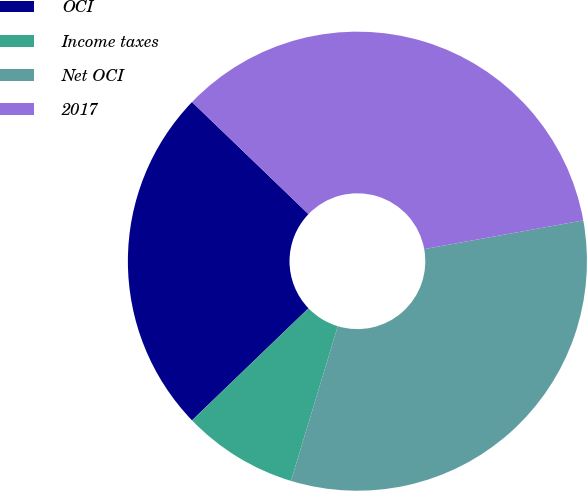<chart> <loc_0><loc_0><loc_500><loc_500><pie_chart><fcel>OCI<fcel>Income taxes<fcel>Net OCI<fcel>2017<nl><fcel>24.39%<fcel>8.13%<fcel>32.52%<fcel>34.96%<nl></chart> 